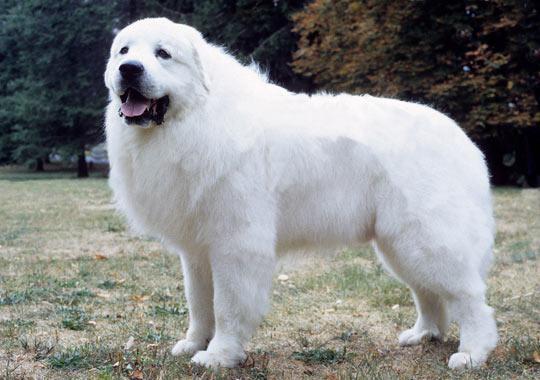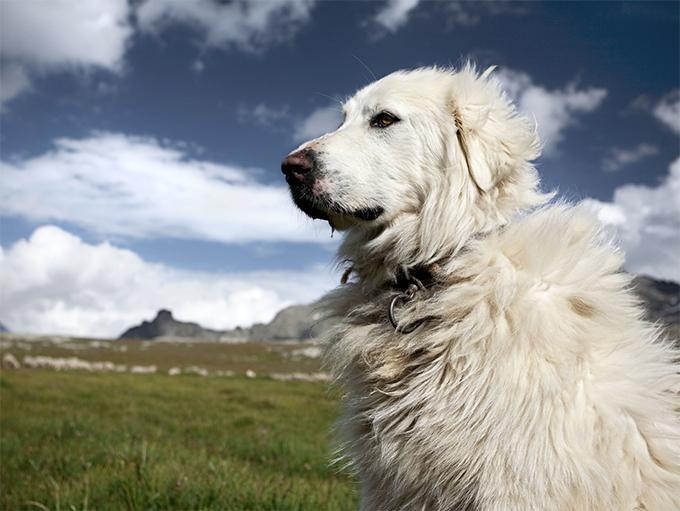The first image is the image on the left, the second image is the image on the right. Given the left and right images, does the statement "An image contains one white dog standing in profile and turned leftward." hold true? Answer yes or no. Yes. The first image is the image on the left, the second image is the image on the right. Given the left and right images, does the statement "There are two dogs in the image pair, both facing the same direction as the other." hold true? Answer yes or no. Yes. 